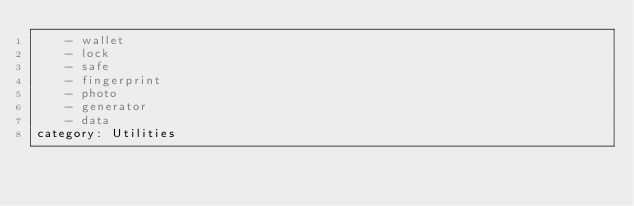Convert code to text. <code><loc_0><loc_0><loc_500><loc_500><_YAML_>    - wallet
    - lock
    - safe
    - fingerprint
    - photo
    - generator
    - data
category: Utilities
</code> 